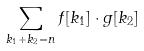<formula> <loc_0><loc_0><loc_500><loc_500>\sum _ { k _ { 1 } + k _ { 2 } = n } f [ k _ { 1 } ] \cdot g [ k _ { 2 } ]</formula> 